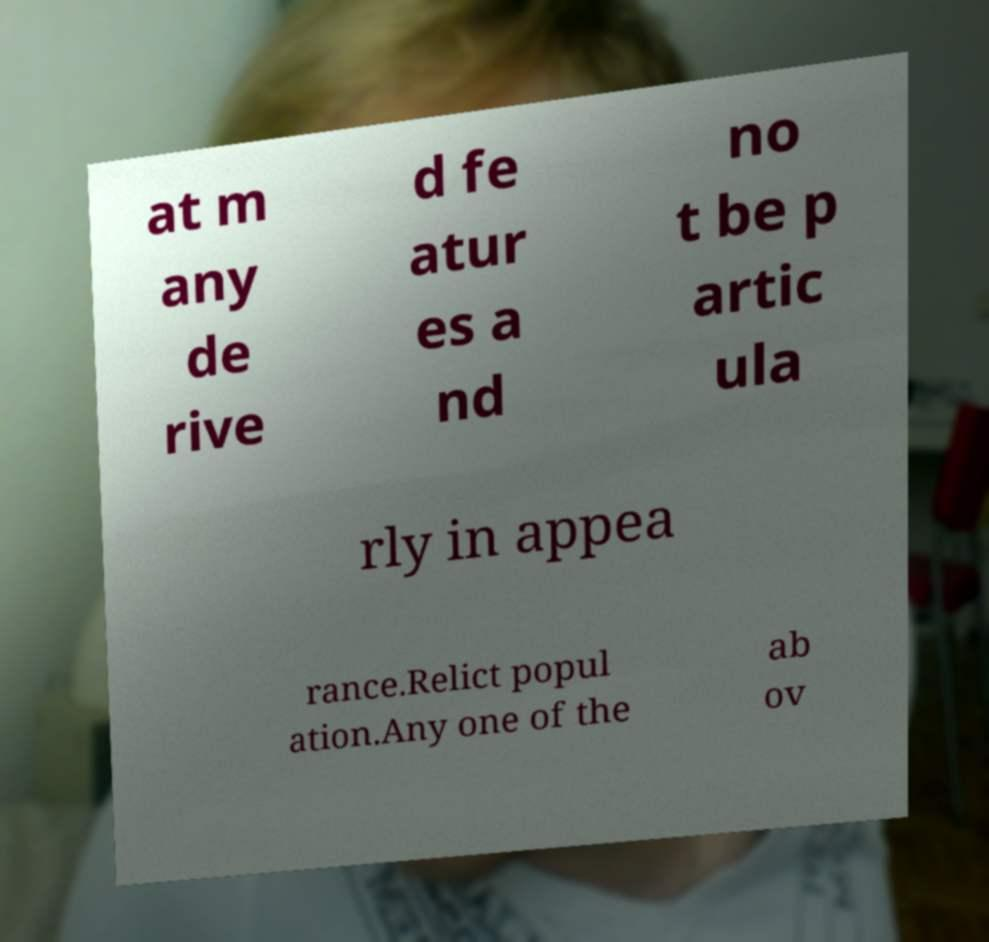I need the written content from this picture converted into text. Can you do that? at m any de rive d fe atur es a nd no t be p artic ula rly in appea rance.Relict popul ation.Any one of the ab ov 